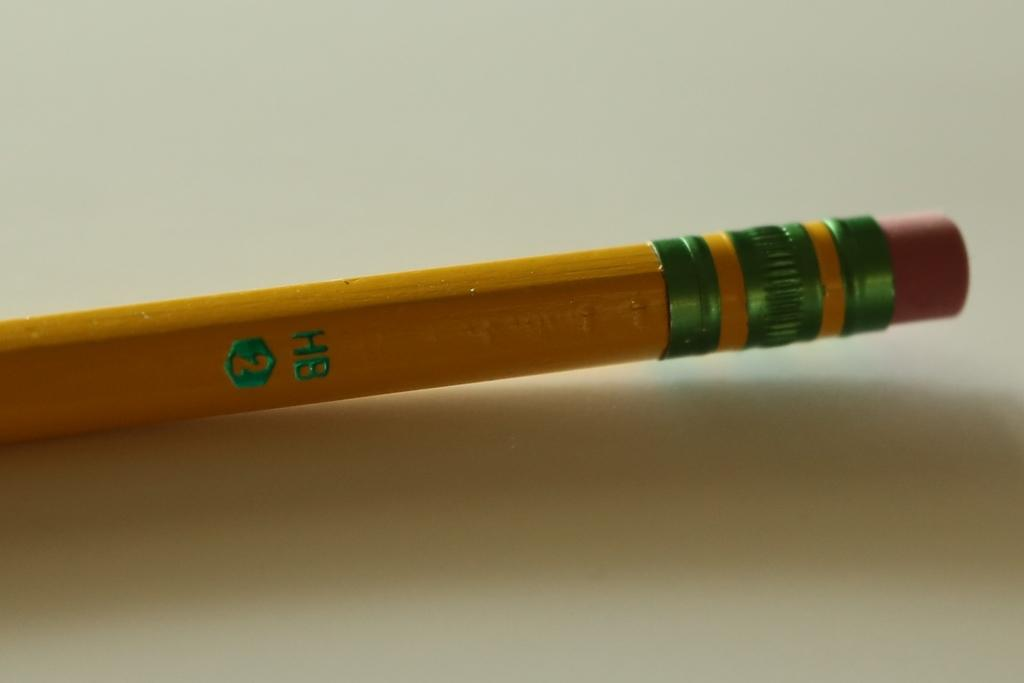<image>
Offer a succinct explanation of the picture presented. A yellow and green wooden number two pencil. 